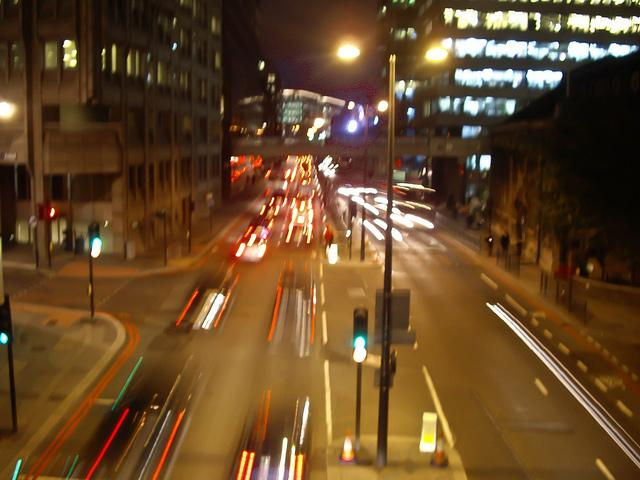What is near the cars? Please explain your reasoning. street lights. You can see the lights at the top of the poles. 